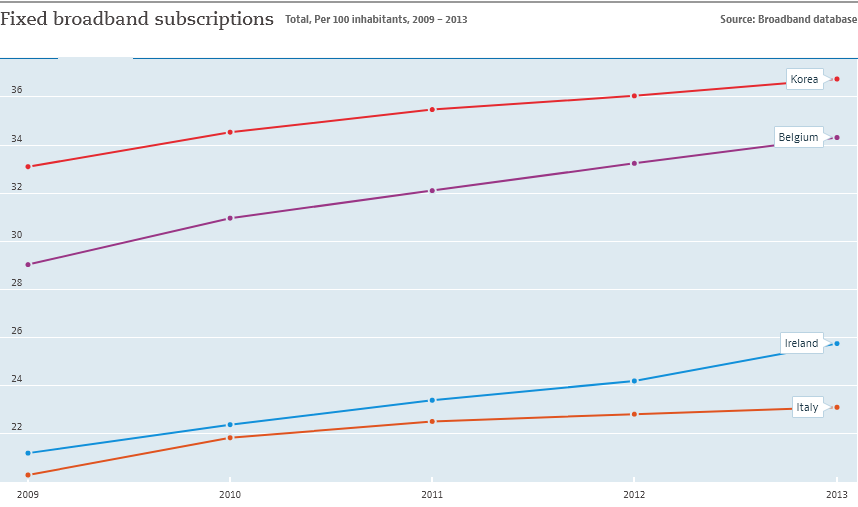List a handful of essential elements in this visual. In 2013, the highest number of fixed broadband subscriptions were recorded in Korea. The fixed broadband subscriptions in Belgium were higher than those in Ireland during the given years. 